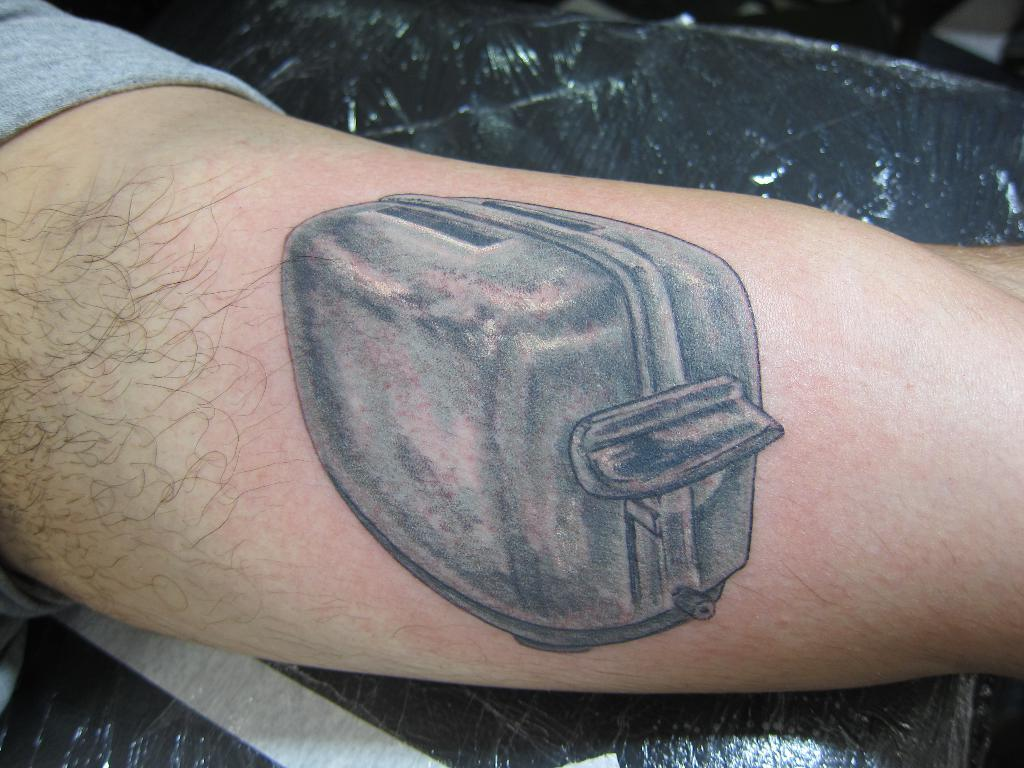What is visible on the person's hand in the image? There is a tattoo on a person's hand in the image. What is the hand with the tattoo touching or holding? The hand with the tattoo is on an object. What type of ink is being used for the dinner in the image? There is no dinner present in the image, and therefore no ink is being used for it. 